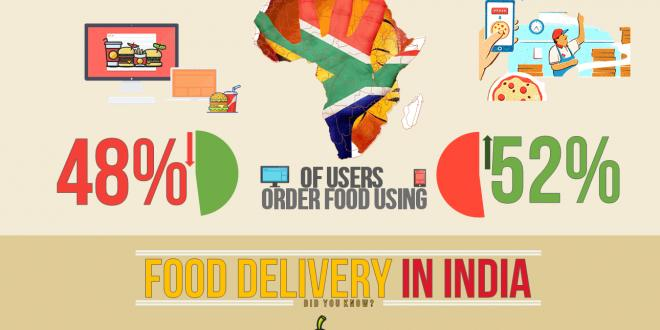Specify some key components in this picture. A 48% drop in users in India who order food online using PC or laptops has been observed. According to a recent survey, there has been a 52% increase in the number of people in India who order food online through their mobile phones. 